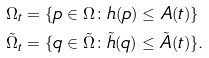Convert formula to latex. <formula><loc_0><loc_0><loc_500><loc_500>\Omega _ { t } & = \{ p \in \Omega \colon h ( p ) \leq A ( t ) \} \\ \tilde { \Omega } _ { t } & = \{ q \in \tilde { \Omega } \colon \tilde { h } ( q ) \leq \tilde { A } ( t ) \} .</formula> 